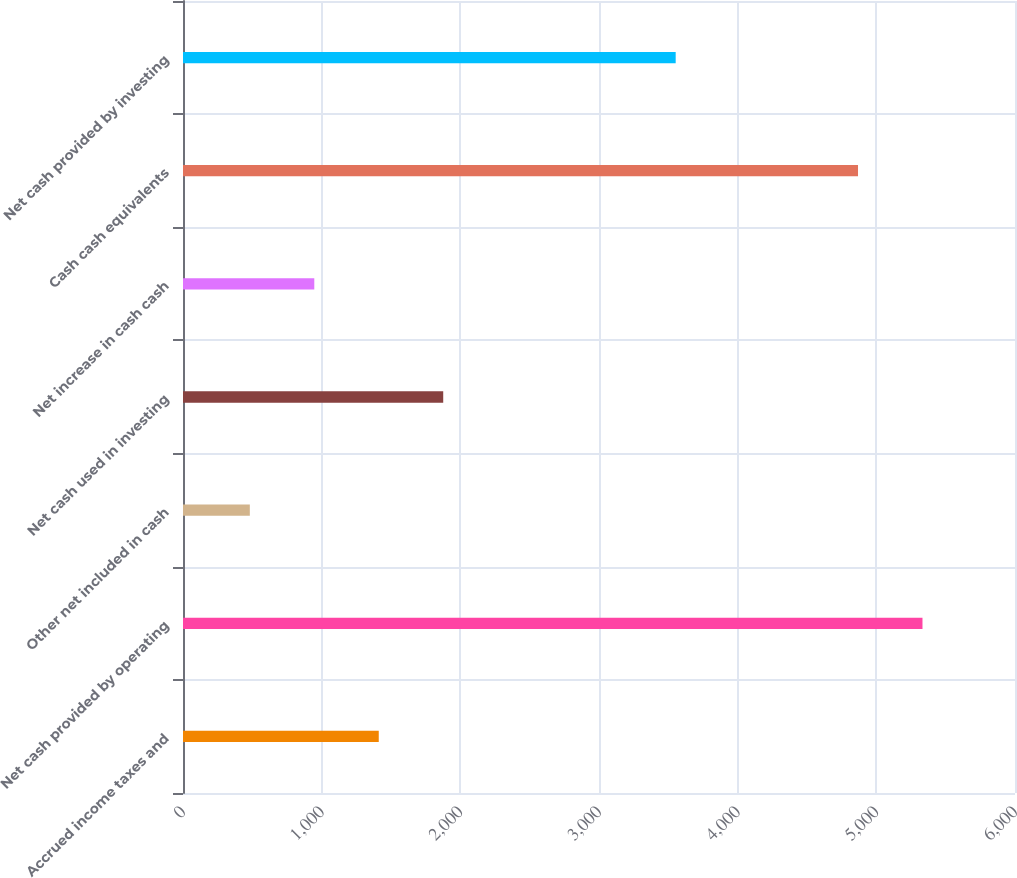<chart> <loc_0><loc_0><loc_500><loc_500><bar_chart><fcel>Accrued income taxes and<fcel>Net cash provided by operating<fcel>Other net included in cash<fcel>Net cash used in investing<fcel>Net increase in cash cash<fcel>Cash cash equivalents<fcel>Net cash provided by investing<nl><fcel>1411.7<fcel>5332.8<fcel>481.9<fcel>1876.6<fcel>946.8<fcel>4867.9<fcel>3553<nl></chart> 